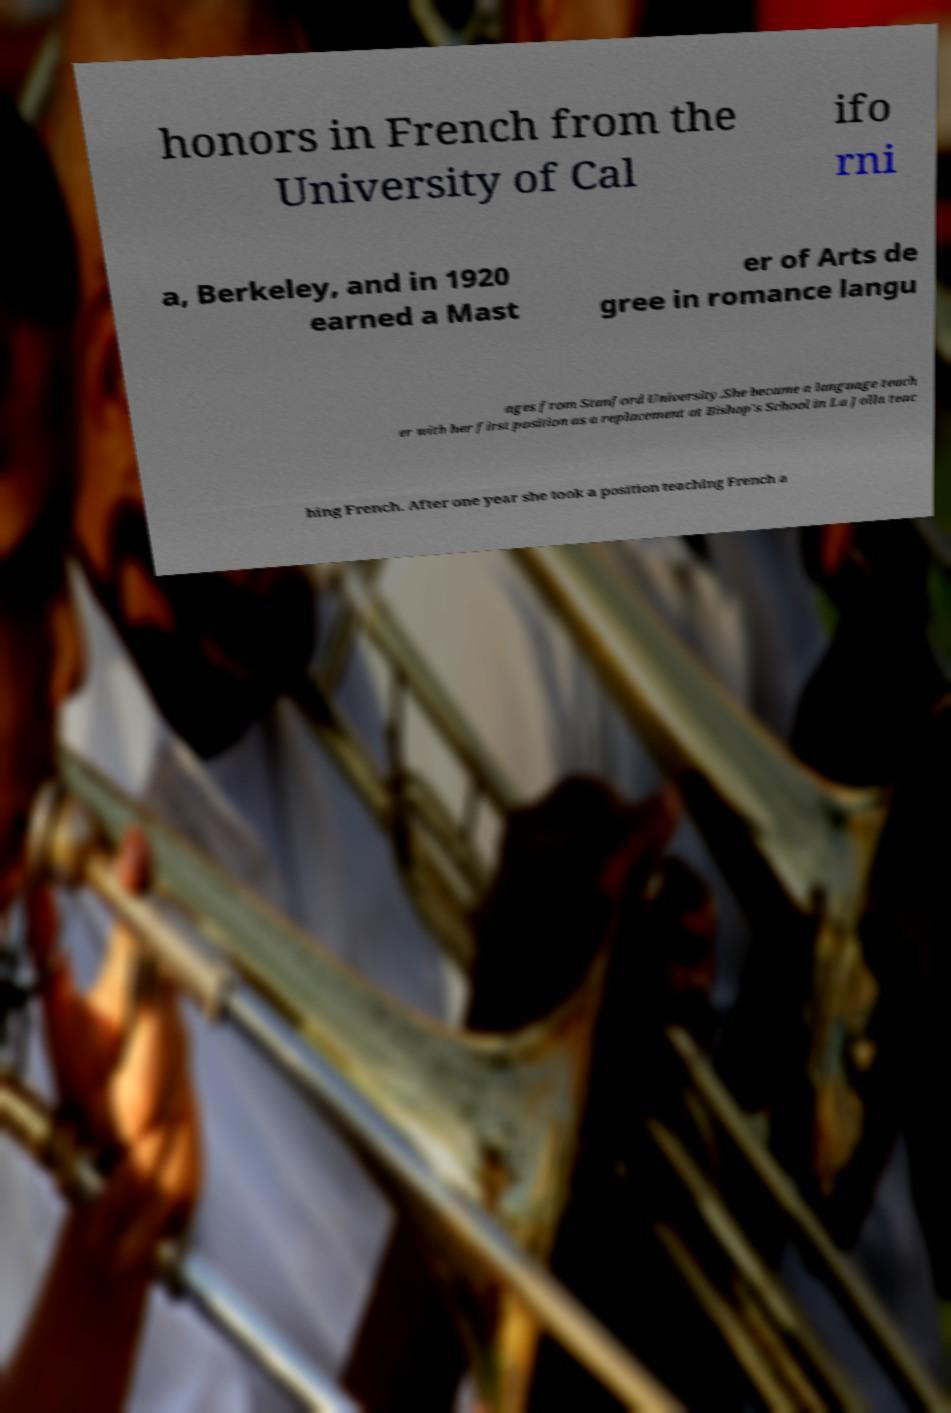For documentation purposes, I need the text within this image transcribed. Could you provide that? honors in French from the University of Cal ifo rni a, Berkeley, and in 1920 earned a Mast er of Arts de gree in romance langu ages from Stanford University.She became a language teach er with her first position as a replacement at Bishop's School in La Jolla teac hing French. After one year she took a position teaching French a 